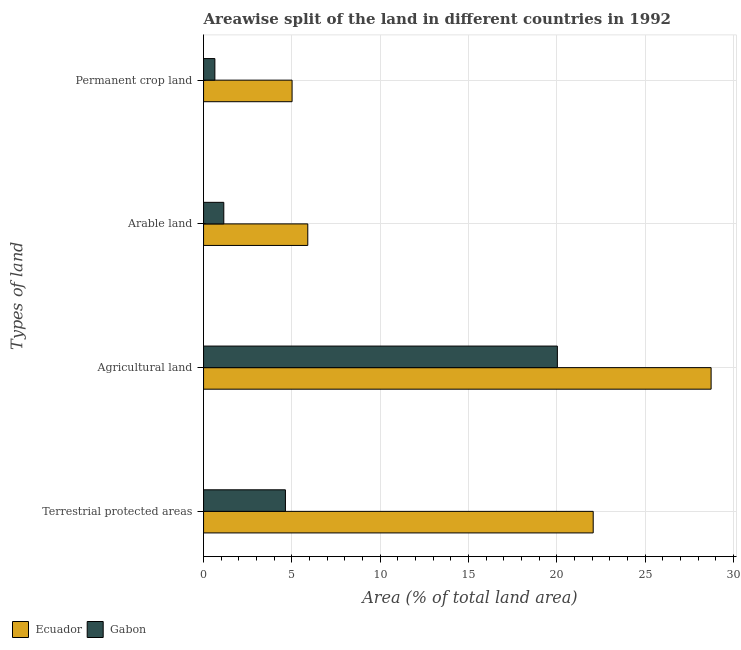Are the number of bars per tick equal to the number of legend labels?
Provide a short and direct response. Yes. Are the number of bars on each tick of the Y-axis equal?
Keep it short and to the point. Yes. How many bars are there on the 2nd tick from the bottom?
Make the answer very short. 2. What is the label of the 2nd group of bars from the top?
Your response must be concise. Arable land. What is the percentage of area under permanent crop land in Gabon?
Provide a short and direct response. 0.64. Across all countries, what is the maximum percentage of area under agricultural land?
Ensure brevity in your answer.  28.73. Across all countries, what is the minimum percentage of area under agricultural land?
Give a very brief answer. 20.03. In which country was the percentage of area under permanent crop land maximum?
Keep it short and to the point. Ecuador. In which country was the percentage of area under arable land minimum?
Ensure brevity in your answer.  Gabon. What is the total percentage of area under arable land in the graph?
Your response must be concise. 7.04. What is the difference between the percentage of area under arable land in Gabon and that in Ecuador?
Offer a terse response. -4.75. What is the difference between the percentage of area under arable land in Gabon and the percentage of land under terrestrial protection in Ecuador?
Your answer should be compact. -20.91. What is the average percentage of land under terrestrial protection per country?
Your answer should be very brief. 13.34. What is the difference between the percentage of area under permanent crop land and percentage of area under arable land in Ecuador?
Offer a very short reply. -0.89. In how many countries, is the percentage of land under terrestrial protection greater than 13 %?
Provide a succinct answer. 1. What is the ratio of the percentage of area under agricultural land in Gabon to that in Ecuador?
Offer a very short reply. 0.7. Is the percentage of area under agricultural land in Gabon less than that in Ecuador?
Provide a succinct answer. Yes. What is the difference between the highest and the second highest percentage of area under permanent crop land?
Make the answer very short. 4.37. What is the difference between the highest and the lowest percentage of area under agricultural land?
Keep it short and to the point. 8.7. In how many countries, is the percentage of area under arable land greater than the average percentage of area under arable land taken over all countries?
Make the answer very short. 1. Is it the case that in every country, the sum of the percentage of land under terrestrial protection and percentage of area under permanent crop land is greater than the sum of percentage of area under arable land and percentage of area under agricultural land?
Your response must be concise. No. What does the 1st bar from the top in Agricultural land represents?
Your response must be concise. Gabon. What does the 2nd bar from the bottom in Permanent crop land represents?
Give a very brief answer. Gabon. Is it the case that in every country, the sum of the percentage of land under terrestrial protection and percentage of area under agricultural land is greater than the percentage of area under arable land?
Keep it short and to the point. Yes. How many bars are there?
Offer a very short reply. 8. How many countries are there in the graph?
Keep it short and to the point. 2. Are the values on the major ticks of X-axis written in scientific E-notation?
Ensure brevity in your answer.  No. Where does the legend appear in the graph?
Your answer should be compact. Bottom left. What is the title of the graph?
Offer a terse response. Areawise split of the land in different countries in 1992. Does "South Sudan" appear as one of the legend labels in the graph?
Offer a very short reply. No. What is the label or title of the X-axis?
Make the answer very short. Area (% of total land area). What is the label or title of the Y-axis?
Keep it short and to the point. Types of land. What is the Area (% of total land area) in Ecuador in Terrestrial protected areas?
Provide a succinct answer. 22.05. What is the Area (% of total land area) of Gabon in Terrestrial protected areas?
Your answer should be very brief. 4.63. What is the Area (% of total land area) in Ecuador in Agricultural land?
Provide a short and direct response. 28.73. What is the Area (% of total land area) of Gabon in Agricultural land?
Provide a succinct answer. 20.03. What is the Area (% of total land area) in Ecuador in Arable land?
Provide a short and direct response. 5.9. What is the Area (% of total land area) in Gabon in Arable land?
Offer a very short reply. 1.14. What is the Area (% of total land area) of Ecuador in Permanent crop land?
Your answer should be very brief. 5.01. What is the Area (% of total land area) of Gabon in Permanent crop land?
Your answer should be compact. 0.64. Across all Types of land, what is the maximum Area (% of total land area) in Ecuador?
Provide a succinct answer. 28.73. Across all Types of land, what is the maximum Area (% of total land area) of Gabon?
Keep it short and to the point. 20.03. Across all Types of land, what is the minimum Area (% of total land area) of Ecuador?
Offer a terse response. 5.01. Across all Types of land, what is the minimum Area (% of total land area) of Gabon?
Ensure brevity in your answer.  0.64. What is the total Area (% of total land area) of Ecuador in the graph?
Make the answer very short. 61.69. What is the total Area (% of total land area) in Gabon in the graph?
Your answer should be very brief. 26.44. What is the difference between the Area (% of total land area) of Ecuador in Terrestrial protected areas and that in Agricultural land?
Offer a very short reply. -6.67. What is the difference between the Area (% of total land area) in Gabon in Terrestrial protected areas and that in Agricultural land?
Ensure brevity in your answer.  -15.39. What is the difference between the Area (% of total land area) of Ecuador in Terrestrial protected areas and that in Arable land?
Give a very brief answer. 16.15. What is the difference between the Area (% of total land area) in Gabon in Terrestrial protected areas and that in Arable land?
Give a very brief answer. 3.49. What is the difference between the Area (% of total land area) in Ecuador in Terrestrial protected areas and that in Permanent crop land?
Provide a short and direct response. 17.04. What is the difference between the Area (% of total land area) in Gabon in Terrestrial protected areas and that in Permanent crop land?
Ensure brevity in your answer.  3.99. What is the difference between the Area (% of total land area) in Ecuador in Agricultural land and that in Arable land?
Offer a terse response. 22.83. What is the difference between the Area (% of total land area) in Gabon in Agricultural land and that in Arable land?
Your answer should be very brief. 18.88. What is the difference between the Area (% of total land area) of Ecuador in Agricultural land and that in Permanent crop land?
Keep it short and to the point. 23.72. What is the difference between the Area (% of total land area) of Gabon in Agricultural land and that in Permanent crop land?
Ensure brevity in your answer.  19.39. What is the difference between the Area (% of total land area) of Ecuador in Arable land and that in Permanent crop land?
Provide a succinct answer. 0.89. What is the difference between the Area (% of total land area) in Gabon in Arable land and that in Permanent crop land?
Make the answer very short. 0.5. What is the difference between the Area (% of total land area) in Ecuador in Terrestrial protected areas and the Area (% of total land area) in Gabon in Agricultural land?
Ensure brevity in your answer.  2.03. What is the difference between the Area (% of total land area) of Ecuador in Terrestrial protected areas and the Area (% of total land area) of Gabon in Arable land?
Give a very brief answer. 20.91. What is the difference between the Area (% of total land area) of Ecuador in Terrestrial protected areas and the Area (% of total land area) of Gabon in Permanent crop land?
Offer a terse response. 21.41. What is the difference between the Area (% of total land area) of Ecuador in Agricultural land and the Area (% of total land area) of Gabon in Arable land?
Offer a very short reply. 27.58. What is the difference between the Area (% of total land area) of Ecuador in Agricultural land and the Area (% of total land area) of Gabon in Permanent crop land?
Offer a very short reply. 28.09. What is the difference between the Area (% of total land area) of Ecuador in Arable land and the Area (% of total land area) of Gabon in Permanent crop land?
Your answer should be very brief. 5.26. What is the average Area (% of total land area) of Ecuador per Types of land?
Keep it short and to the point. 15.42. What is the average Area (% of total land area) in Gabon per Types of land?
Your response must be concise. 6.61. What is the difference between the Area (% of total land area) in Ecuador and Area (% of total land area) in Gabon in Terrestrial protected areas?
Your answer should be compact. 17.42. What is the difference between the Area (% of total land area) of Ecuador and Area (% of total land area) of Gabon in Agricultural land?
Give a very brief answer. 8.7. What is the difference between the Area (% of total land area) in Ecuador and Area (% of total land area) in Gabon in Arable land?
Your response must be concise. 4.75. What is the difference between the Area (% of total land area) of Ecuador and Area (% of total land area) of Gabon in Permanent crop land?
Keep it short and to the point. 4.37. What is the ratio of the Area (% of total land area) of Ecuador in Terrestrial protected areas to that in Agricultural land?
Provide a succinct answer. 0.77. What is the ratio of the Area (% of total land area) in Gabon in Terrestrial protected areas to that in Agricultural land?
Your response must be concise. 0.23. What is the ratio of the Area (% of total land area) of Ecuador in Terrestrial protected areas to that in Arable land?
Keep it short and to the point. 3.74. What is the ratio of the Area (% of total land area) of Gabon in Terrestrial protected areas to that in Arable land?
Keep it short and to the point. 4.05. What is the ratio of the Area (% of total land area) of Ecuador in Terrestrial protected areas to that in Permanent crop land?
Keep it short and to the point. 4.4. What is the ratio of the Area (% of total land area) of Gabon in Terrestrial protected areas to that in Permanent crop land?
Your answer should be very brief. 7.23. What is the ratio of the Area (% of total land area) of Ecuador in Agricultural land to that in Arable land?
Make the answer very short. 4.87. What is the ratio of the Area (% of total land area) in Gabon in Agricultural land to that in Arable land?
Give a very brief answer. 17.49. What is the ratio of the Area (% of total land area) in Ecuador in Agricultural land to that in Permanent crop land?
Ensure brevity in your answer.  5.73. What is the ratio of the Area (% of total land area) of Gabon in Agricultural land to that in Permanent crop land?
Keep it short and to the point. 31.27. What is the ratio of the Area (% of total land area) of Ecuador in Arable land to that in Permanent crop land?
Keep it short and to the point. 1.18. What is the ratio of the Area (% of total land area) of Gabon in Arable land to that in Permanent crop land?
Provide a short and direct response. 1.79. What is the difference between the highest and the second highest Area (% of total land area) of Ecuador?
Ensure brevity in your answer.  6.67. What is the difference between the highest and the second highest Area (% of total land area) of Gabon?
Provide a short and direct response. 15.39. What is the difference between the highest and the lowest Area (% of total land area) of Ecuador?
Give a very brief answer. 23.72. What is the difference between the highest and the lowest Area (% of total land area) in Gabon?
Offer a terse response. 19.39. 